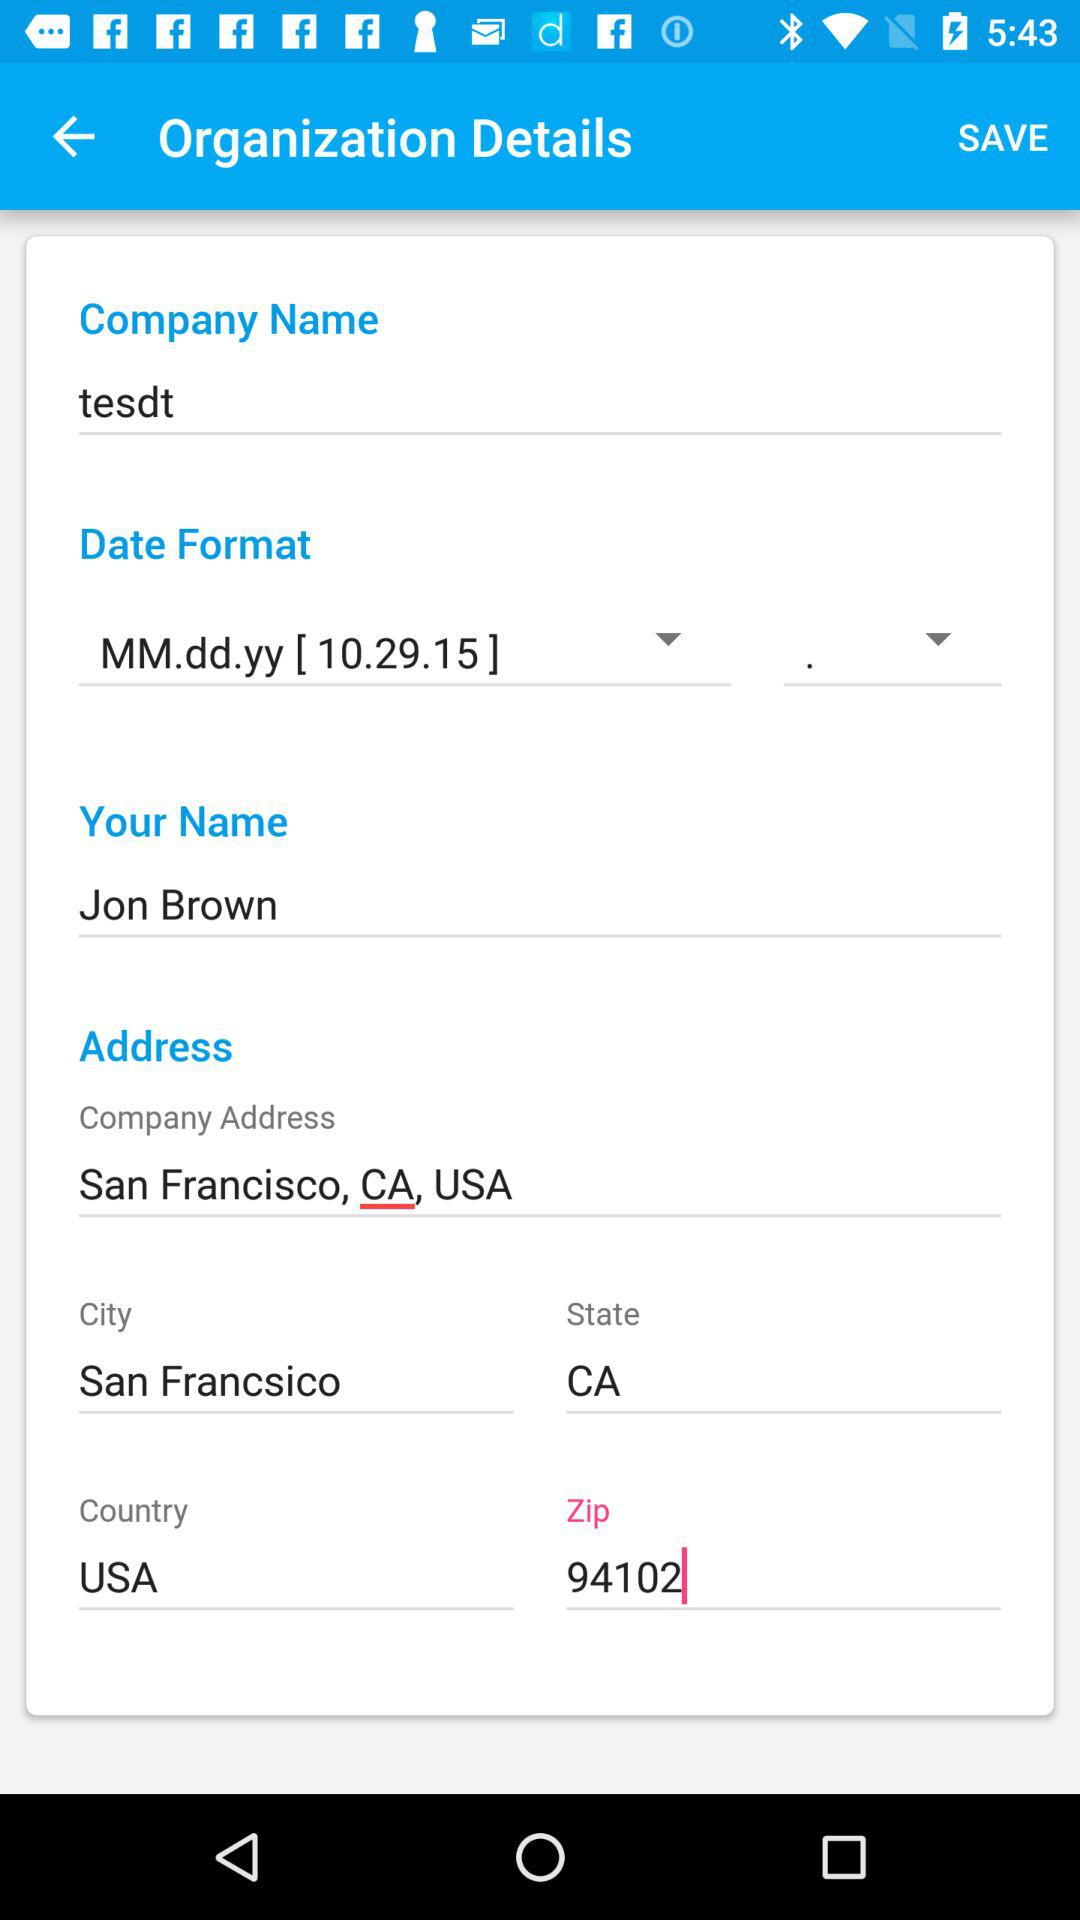What is the company address? The company address is San Francisco, CA, USA. 